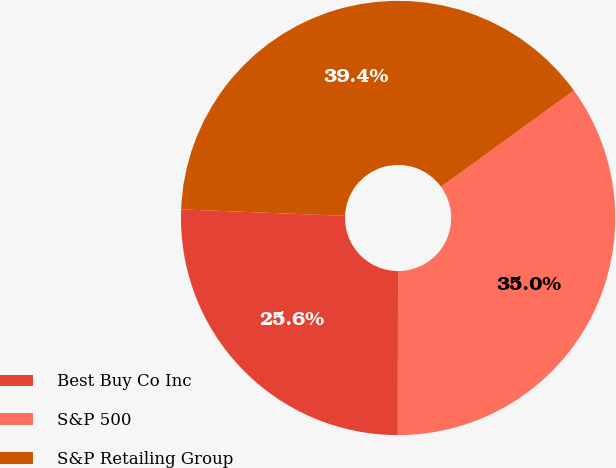Convert chart. <chart><loc_0><loc_0><loc_500><loc_500><pie_chart><fcel>Best Buy Co Inc<fcel>S&P 500<fcel>S&P Retailing Group<nl><fcel>25.61%<fcel>35.01%<fcel>39.38%<nl></chart> 